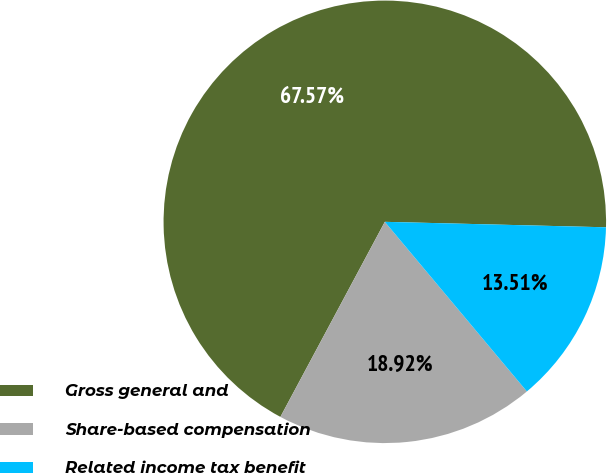Convert chart to OTSL. <chart><loc_0><loc_0><loc_500><loc_500><pie_chart><fcel>Gross general and<fcel>Share-based compensation<fcel>Related income tax benefit<nl><fcel>67.57%<fcel>18.92%<fcel>13.51%<nl></chart> 